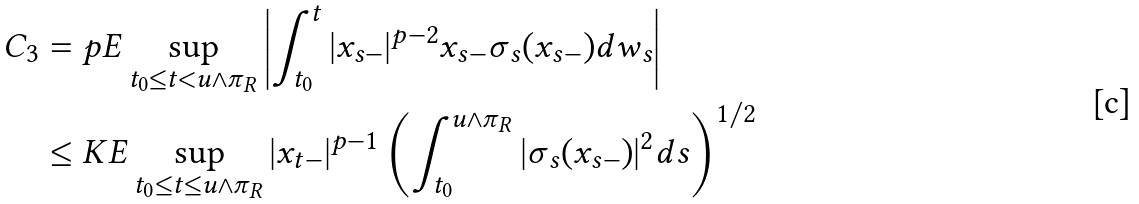<formula> <loc_0><loc_0><loc_500><loc_500>C _ { 3 } & = p E \sup _ { t _ { 0 } \leq t < u \wedge \pi _ { R } } \left | \int _ { t _ { 0 } } ^ { t } | x _ { s - } | ^ { p - 2 } x _ { s - } \sigma _ { s } ( x _ { s - } ) d w _ { s } \right | \\ & \leq K E \sup _ { t _ { 0 } \leq t \leq u \wedge \pi _ { R } } | x _ { t - } | ^ { p - 1 } \left ( \int _ { t _ { 0 } } ^ { u \wedge \pi _ { R } } | \sigma _ { s } ( x _ { s - } ) | ^ { 2 } d s \right ) ^ { 1 / 2 }</formula> 